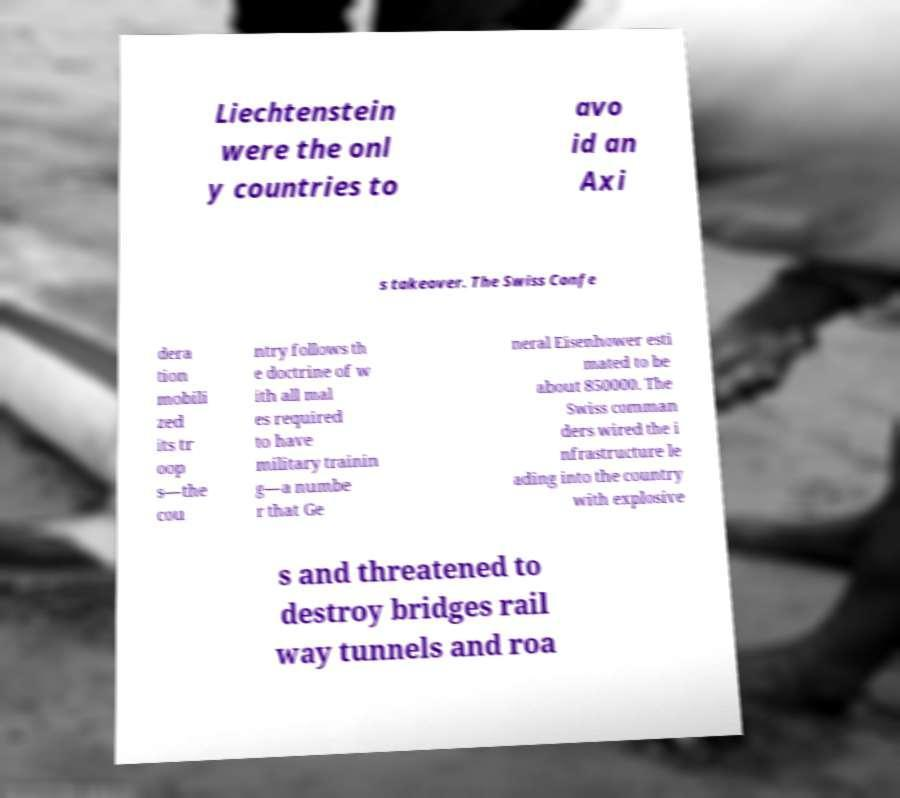Please read and relay the text visible in this image. What does it say? Liechtenstein were the onl y countries to avo id an Axi s takeover. The Swiss Confe dera tion mobili zed its tr oop s—the cou ntry follows th e doctrine of w ith all mal es required to have military trainin g—a numbe r that Ge neral Eisenhower esti mated to be about 850000. The Swiss comman ders wired the i nfrastructure le ading into the country with explosive s and threatened to destroy bridges rail way tunnels and roa 